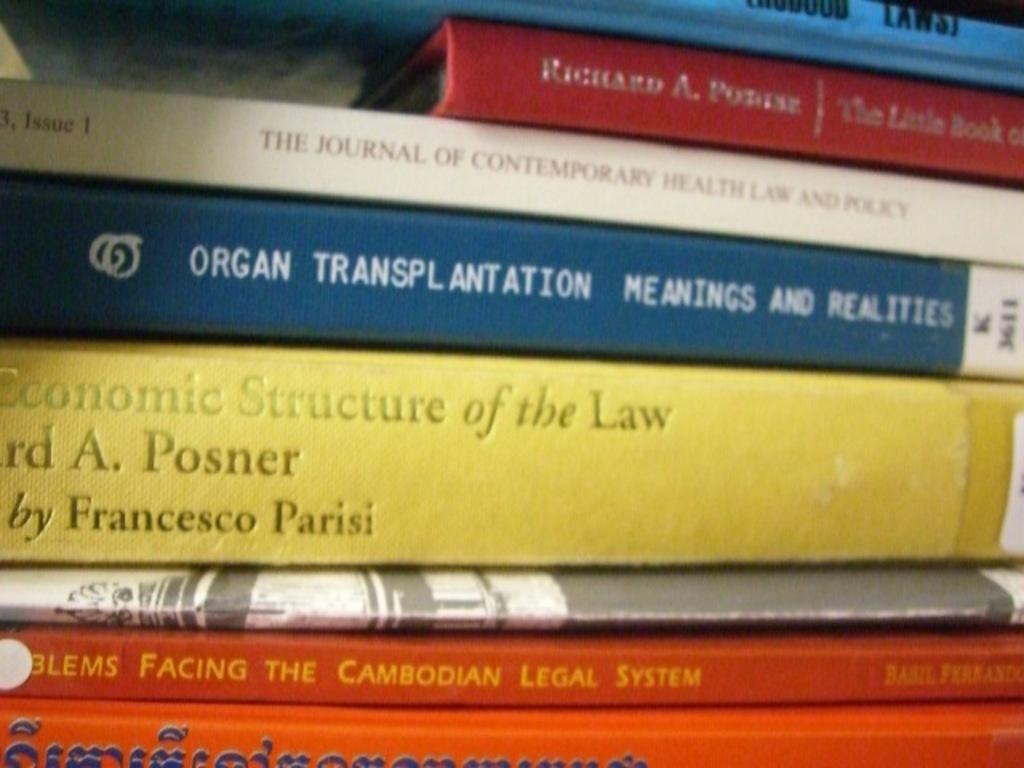<image>
Create a compact narrative representing the image presented. A book titled Organ Transplantation is in the middle of a stack of books. 